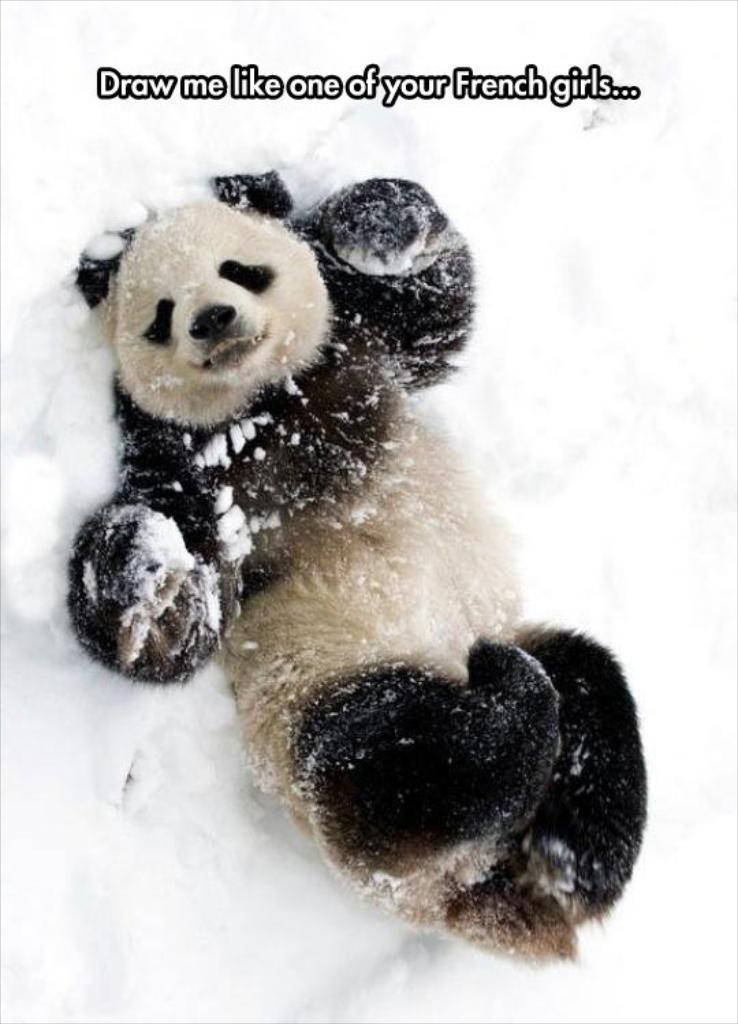Describe this image in one or two sentences. In the center of the image there is a panda on the snow. 